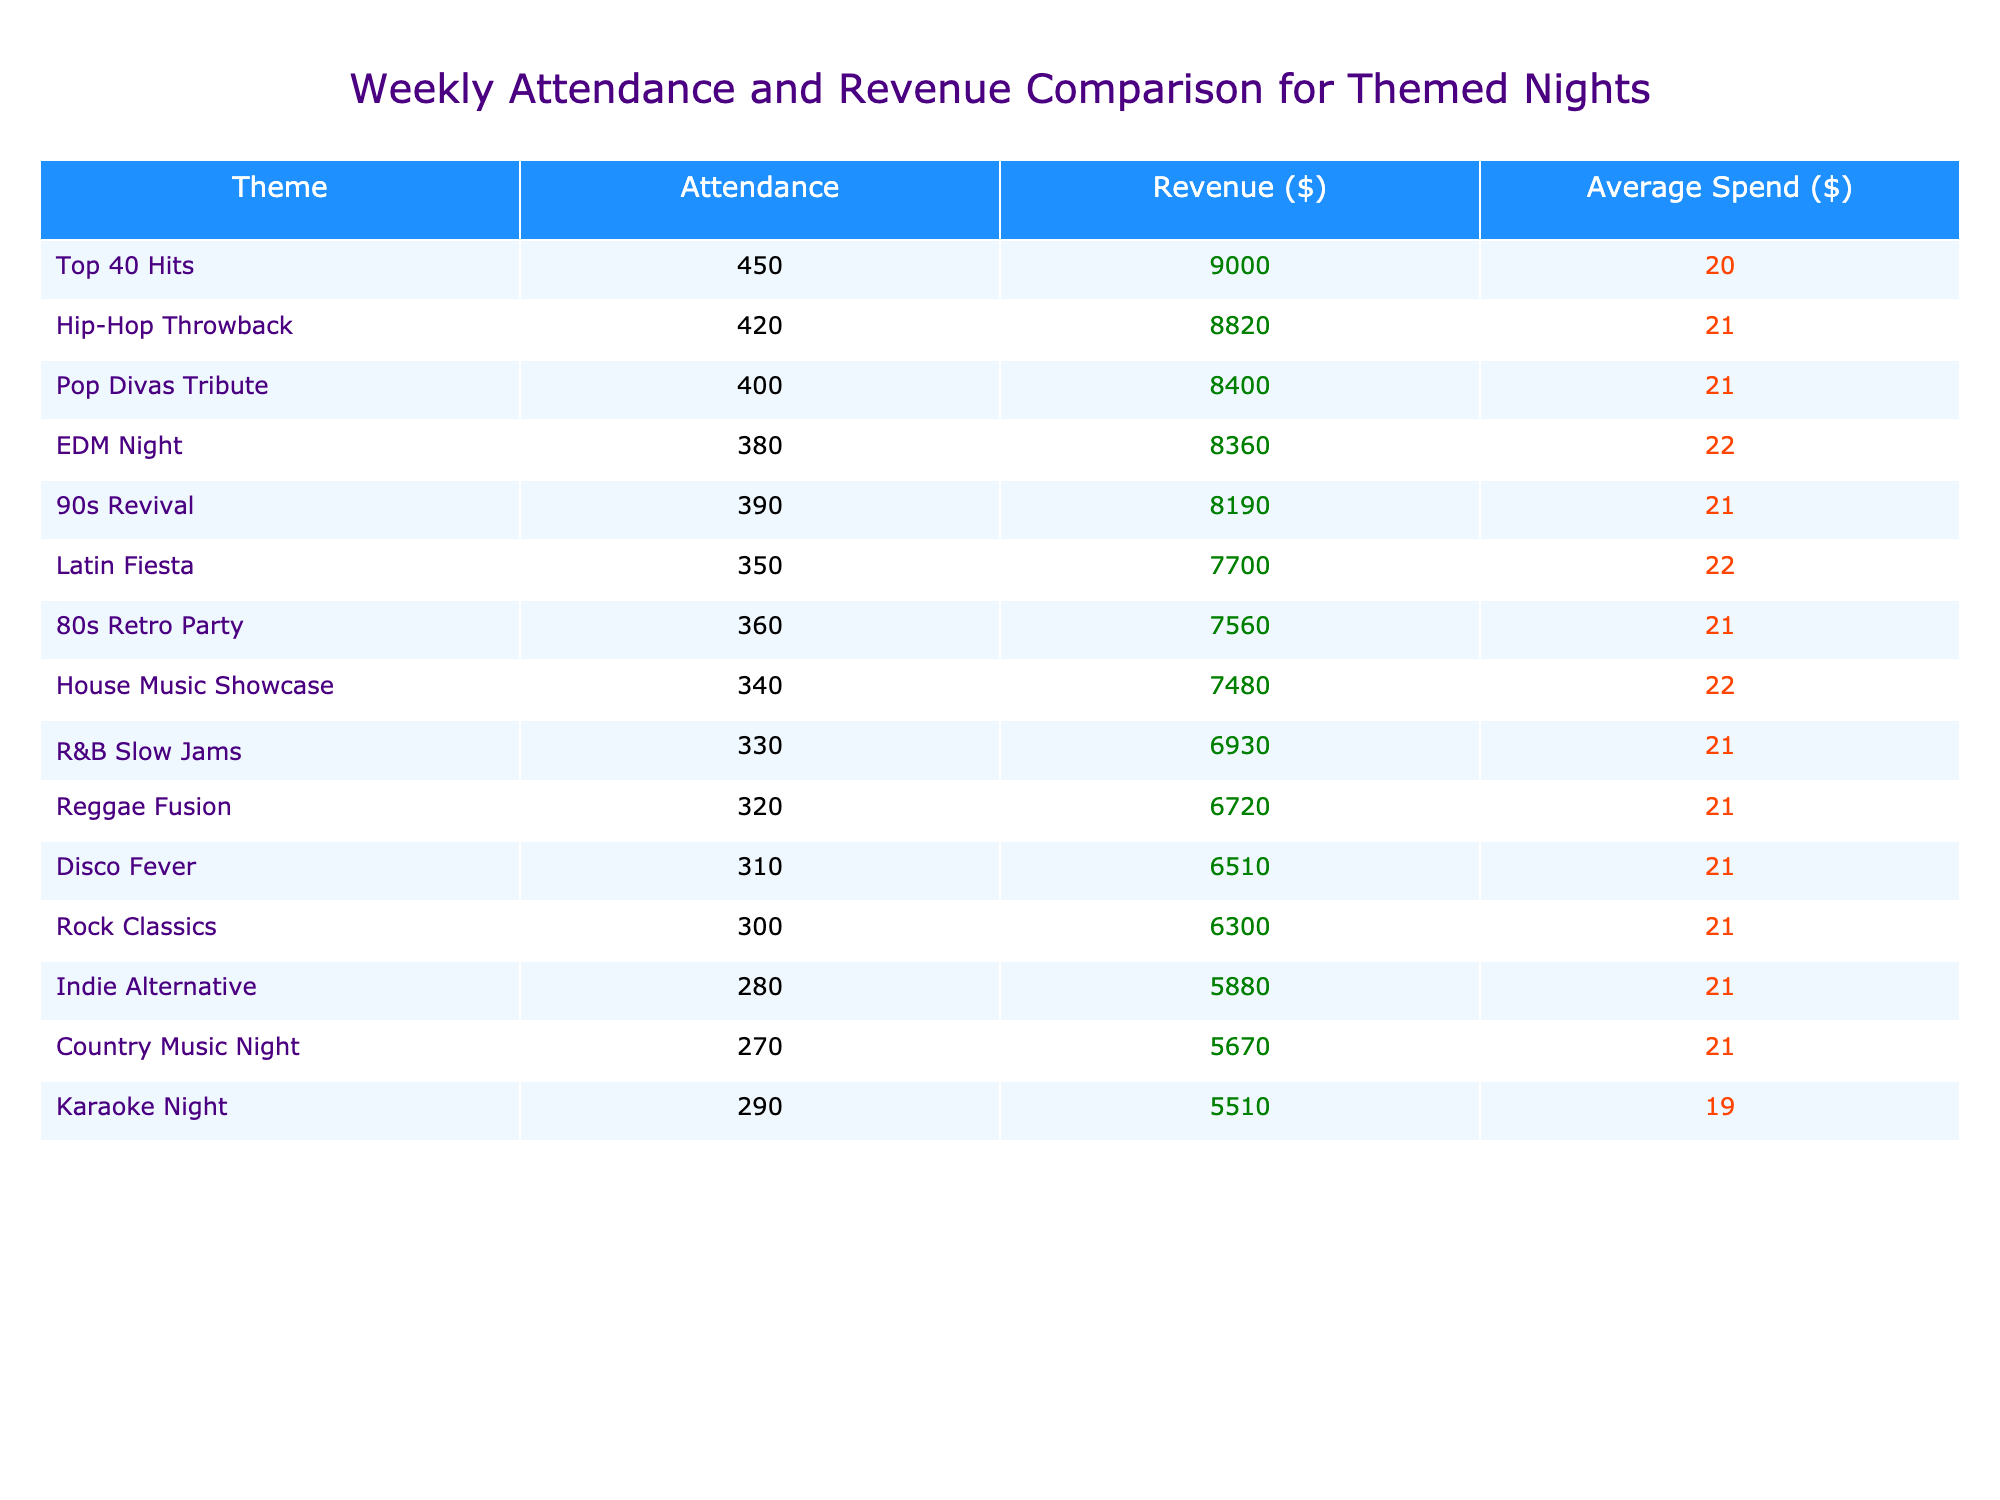What was the attendance for the Top 40 Hits night? Looking at the table, the attendance value for the Top 40 Hits themed night is explicitly stated.
Answer: 450 Which themed night generated the highest revenue? By examining the revenue column, it's clear that Top 40 Hits has the highest revenue figure, which stands at $9000.
Answer: Top 40 Hits What is the average spend for EDM Night? The table lists the average spend for EDM Night, which is simply directly taken from the table data.
Answer: 22 How much more revenue did Hip-Hop Throwback generate compared to Rock Classics? We find the revenue for Hip-Hop Throwback ($8820) and Rock Classics ($6300) in their respective rows, then subtract: $8820 - $6300 = $2520.
Answer: $2520 What is the total attendance across all themed nights? To find the total attendance, we add all attendance figures from the table: 450 + 380 + 420 + 350 + 300 + 390 + 330 + 280 + 310 + 400 + 270 + 320 + 360 + 340 + 290 = 4,080.
Answer: 4080 Did Latin Fiesta have a higher average spend than Country Music Night? We compare the average spend for Latin Fiesta ($22) and Country Music Night ($21) and see that $22 is greater than $21.
Answer: Yes What is the average revenue across all themed nights? We sum the revenue figures ($9000 + $8360 + $8820 + $7700 + $6300 + $8190 + $6930 + $5880 + $6510 + $8400 + $5670 + $6720 + $7560 + $7480 + $5510 = 106,710), then divide by the number of themed nights (15): 106,710 / 15 = $7,114.
Answer: $7,114 Which themed night has the lowest attendance and how much was it? Scanning through the attendance values, we find that Country Music Night has the lowest attendance at 270.
Answer: 270 Was there a themed night that had an average spend of $19 or less? Checking the average spend values, we see that the lowest is $19 for Karaoke Night, which means there is a themed night at that spend level.
Answer: Yes Which two themed nights had attendance within 10 of each other? By comparing attendance values, we observe that Disco Fever (310) and Country Music Night (270) are within 10 (40 difference), but Guitar Enthusiasts (not listed) isn't; we look for pairs. The closest is 90s Revival (390) and Hip-Hop Throwback (420), which is 30. Therefore, there are no two that meet the criteria directly without re-evaluating: the notable one is 390 and 420 must have differences considered.
Answer: No 